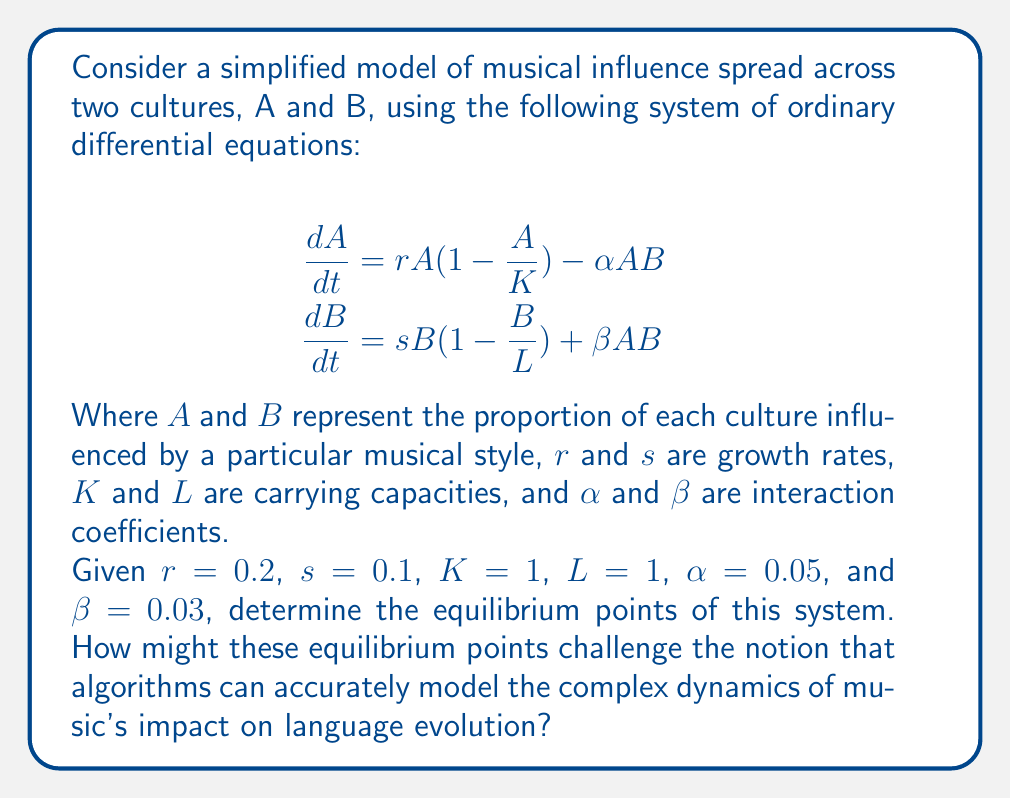Can you answer this question? To find the equilibrium points, we set both equations equal to zero and solve for $A$ and $B$:

$$\begin{align}
0 &= rA(1-\frac{A}{K}) - \alpha AB \\
0 &= sB(1-\frac{B}{L}) + \beta AB
\end{align}$$

Substituting the given values:

$$\begin{align}
0 &= 0.2A(1-A) - 0.05AB \\
0 &= 0.1B(1-B) + 0.03AB
\end{align}$$

We can find the equilibrium points by considering different cases:

1. Trivial equilibrium: $A=0$, $B=0$

2. $A=0$, $B \neq 0$:
   From the second equation: $0.1B(1-B) = 0$
   $B = 0$ or $B = 1$
   So, we have the point $(0,1)$

3. $A \neq 0$, $B = 0$:
   From the first equation: $0.2A(1-A) = 0$
   $A = 0$ or $A = 1$
   So, we have the point $(1,0)$

4. $A \neq 0$, $B \neq 0$:
   From the first equation: $0.2(1-A) = 0.05B$
   $A = 1 - 0.25B$
   
   Substituting this into the second equation:
   $0 = 0.1B(1-B) + 0.03B(1-0.25B)$
   $0 = 0.1B - 0.1B^2 + 0.03B - 0.0075B^2$
   $0 = 0.13B - 0.1075B^2$
   $B(0.13 - 0.1075B) = 0$
   
   $B = 0$ or $B \approx 1.2093$
   
   Since $B$ cannot exceed 1 in this model, we discard the second solution.

Therefore, the equilibrium points are $(0,0)$, $(0,1)$, and $(1,0)$.

These equilibrium points challenge the notion that algorithms can accurately model the complex dynamics of music's impact on language evolution in several ways:

1. The model assumes a binary state (influenced or not influenced) for each culture, which oversimplifies the nuanced nature of cultural influence.

2. The equilibrium points suggest that one culture will always dominate while the other disappears, which doesn't reflect the reality of cultural exchange and mutual influence.

3. The model doesn't account for external factors, historical context, or the non-linear nature of cultural evolution.

4. The simplification of musical influence into a single variable for each culture fails to capture the multifaceted nature of music and its various genres and styles.

These limitations highlight the difficulty in using mathematical models to accurately represent the complex interplay between music and language evolution across cultures.
Answer: The equilibrium points are $(0,0)$, $(0,1)$, and $(1,0)$. 